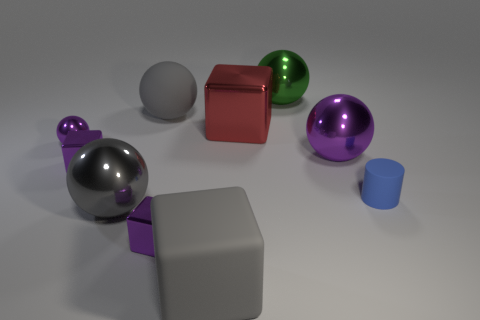How many purple blocks must be subtracted to get 1 purple blocks? 1 Subtract all green balls. How many balls are left? 4 Subtract all green shiny balls. How many balls are left? 4 Subtract all blue spheres. Subtract all cyan blocks. How many spheres are left? 5 Subtract all cubes. How many objects are left? 6 Add 10 big yellow things. How many big yellow things exist? 10 Subtract 0 red balls. How many objects are left? 10 Subtract all matte cylinders. Subtract all big blue spheres. How many objects are left? 9 Add 4 big gray things. How many big gray things are left? 7 